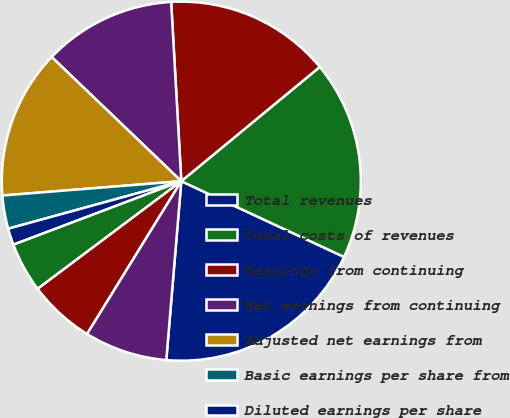<chart> <loc_0><loc_0><loc_500><loc_500><pie_chart><fcel>Total revenues<fcel>Total costs of revenues<fcel>Earnings from continuing<fcel>Net earnings from continuing<fcel>Adjusted net earnings from<fcel>Basic earnings per share from<fcel>Diluted earnings per share<fcel>Adjusted diluted earnings per<fcel>Basic weighted average shares<fcel>Diluted weighted average<nl><fcel>19.4%<fcel>17.91%<fcel>14.92%<fcel>11.94%<fcel>13.43%<fcel>2.99%<fcel>1.49%<fcel>4.48%<fcel>5.97%<fcel>7.46%<nl></chart> 